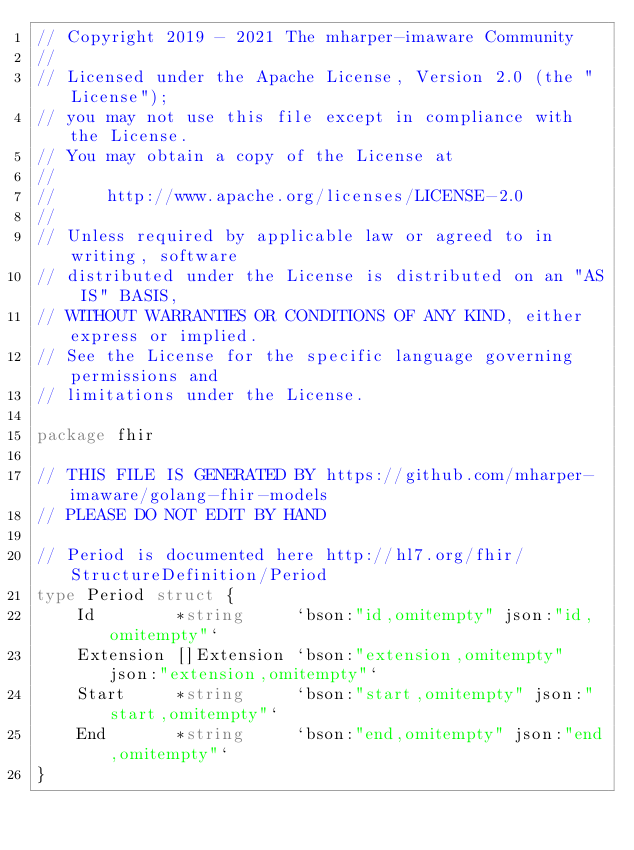Convert code to text. <code><loc_0><loc_0><loc_500><loc_500><_Go_>// Copyright 2019 - 2021 The mharper-imaware Community
//
// Licensed under the Apache License, Version 2.0 (the "License");
// you may not use this file except in compliance with the License.
// You may obtain a copy of the License at
//
//     http://www.apache.org/licenses/LICENSE-2.0
//
// Unless required by applicable law or agreed to in writing, software
// distributed under the License is distributed on an "AS IS" BASIS,
// WITHOUT WARRANTIES OR CONDITIONS OF ANY KIND, either express or implied.
// See the License for the specific language governing permissions and
// limitations under the License.

package fhir

// THIS FILE IS GENERATED BY https://github.com/mharper-imaware/golang-fhir-models
// PLEASE DO NOT EDIT BY HAND

// Period is documented here http://hl7.org/fhir/StructureDefinition/Period
type Period struct {
	Id        *string     `bson:"id,omitempty" json:"id,omitempty"`
	Extension []Extension `bson:"extension,omitempty" json:"extension,omitempty"`
	Start     *string     `bson:"start,omitempty" json:"start,omitempty"`
	End       *string     `bson:"end,omitempty" json:"end,omitempty"`
}
</code> 